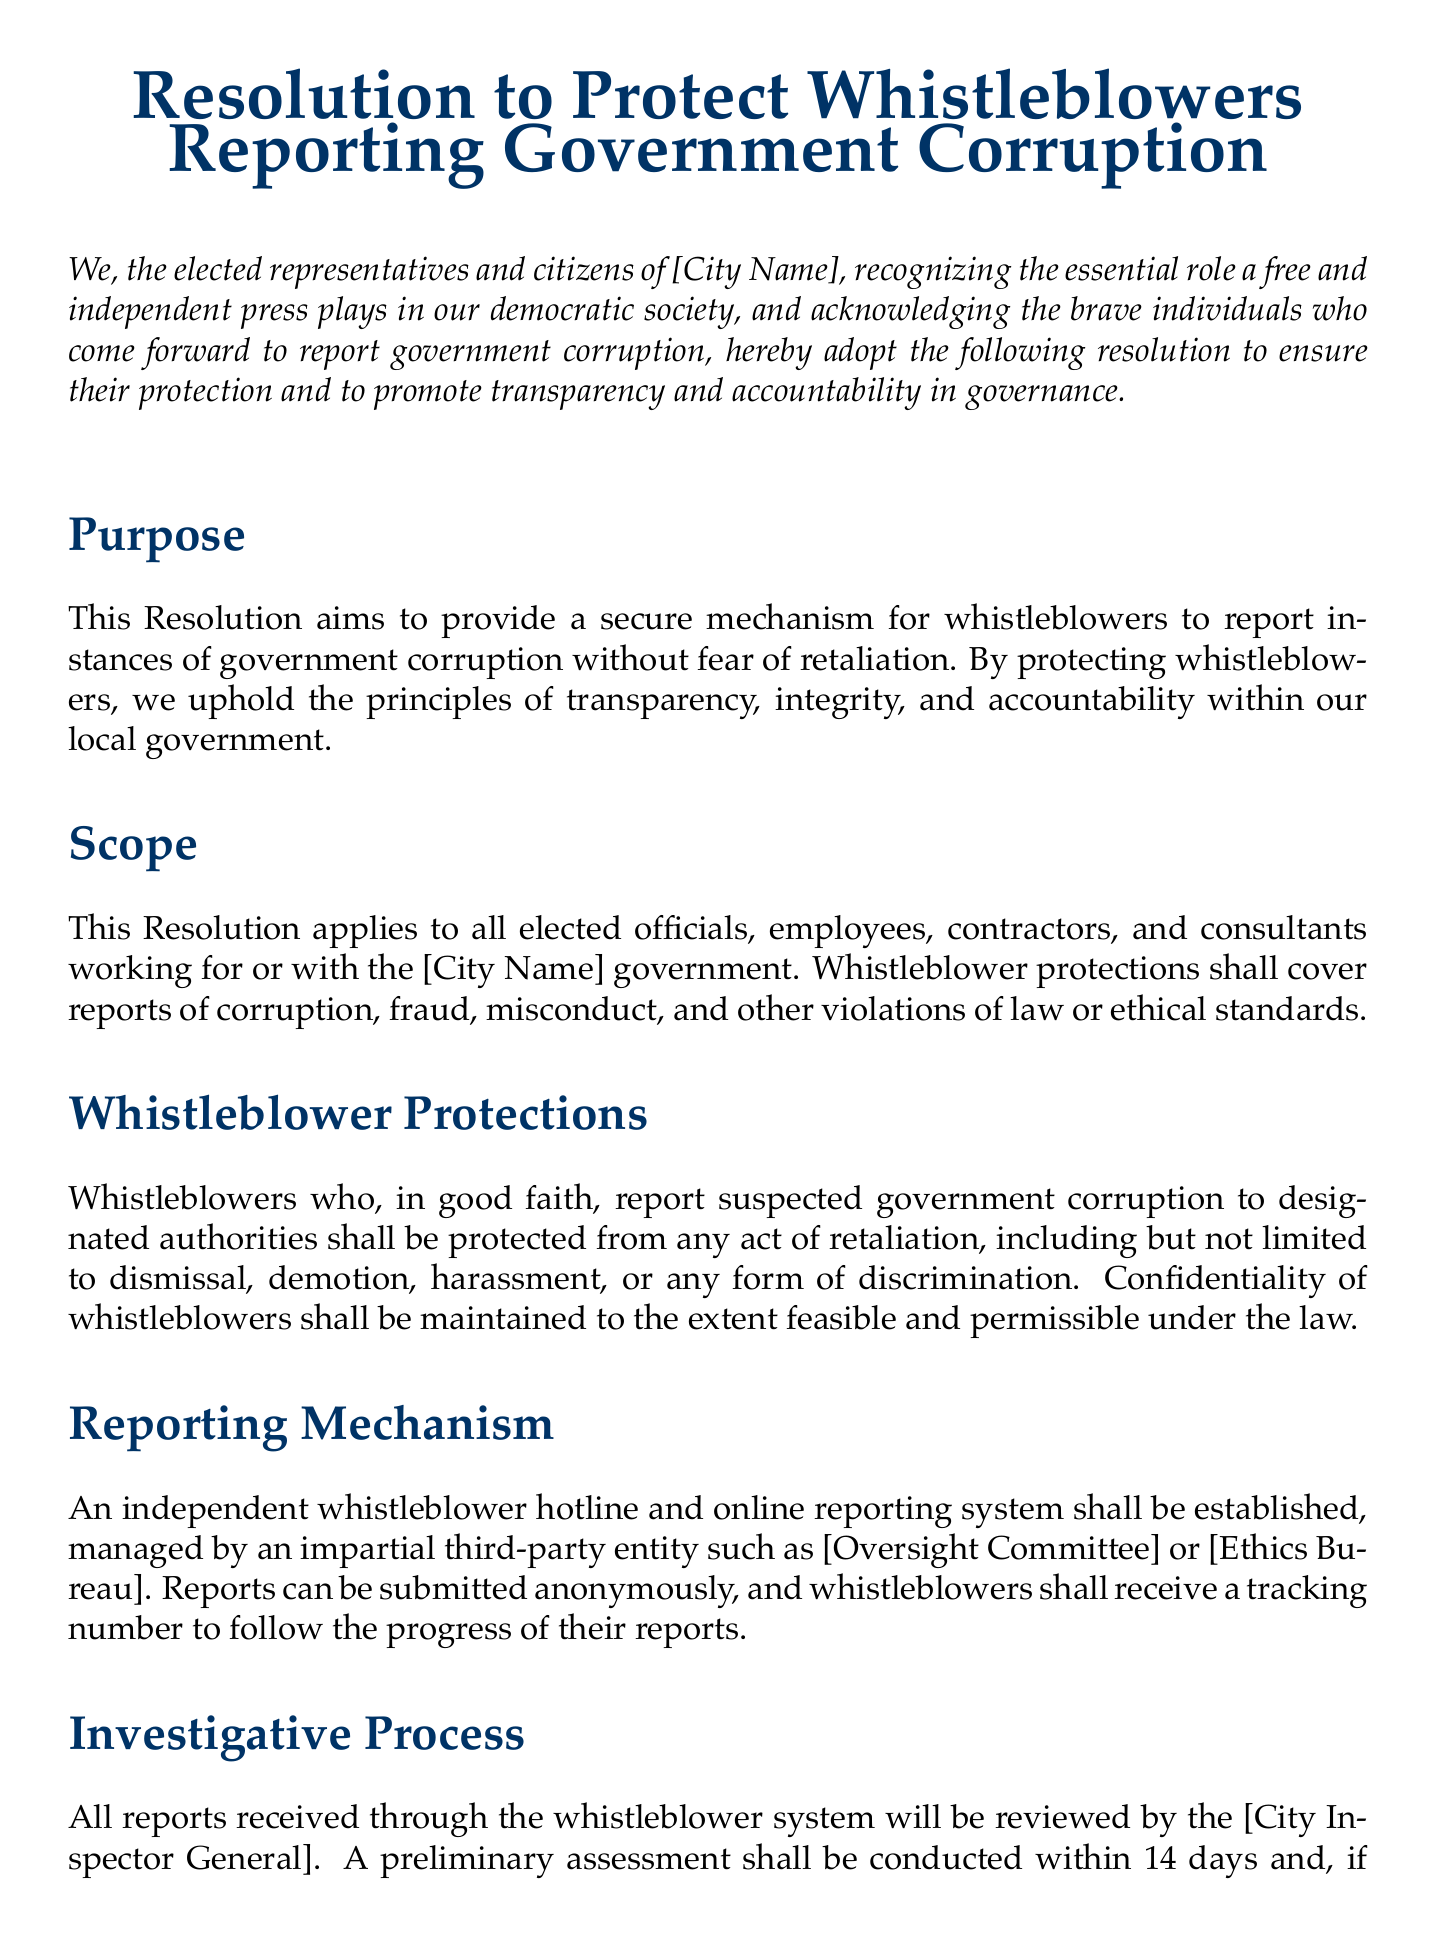What is the title of the resolution? The title of the resolution is stated at the beginning of the document, which identifies its purpose.
Answer: Resolution to Protect Whistleblowers Reporting Government Corruption Who does this resolution apply to? The document specifies that the resolution applies to those associated with the local government, including various roles.
Answer: All elected officials, employees, contractors, and consultants What is the effective date of the resolution? The effective date is noted towards the end of the document and signifies when the resolution is active.
Answer: Immediately upon adoption How long does the City Inspector General have to conduct a preliminary assessment? The time frame for an initial assessment is explicitly stated in the document to ensure timely action on reports.
Answer: 14 days What protections are offered to whistleblowers? This section outlines the specific protections to ensure that whistleblowers can report without fear.
Answer: From any act of retaliation What is the duration within which findings must be disclosed? The document specifies a time frame for when findings should be made public to maintain transparency.
Answer: 60 days of resolution Which entity will manage the independent whistleblower hotline? The document mentions who is tasked with managing the reporting system to ensure impartiality.
Answer: Independent third-party entity such as [Oversight Committee] or [Ethics Bureau] What type of training will be conducted for city employees? This section discusses what kind of training initiatives will take place to educate staff regarding whistleblower protections.
Answer: Annual training programs What is the purpose of this resolution? The purpose is clearly stated in a designated section of the document outlining its main objectives.
Answer: To provide a secure mechanism for whistleblowers to report instances of government corruption without fear of retaliation 